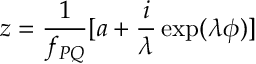<formula> <loc_0><loc_0><loc_500><loc_500>z = \frac { 1 } { f _ { P Q } } [ a + \frac { i } { \lambda } \exp ( \lambda \phi ) ]</formula> 